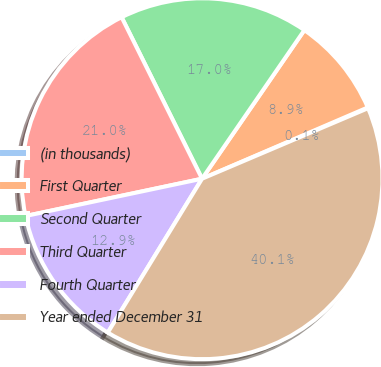Convert chart to OTSL. <chart><loc_0><loc_0><loc_500><loc_500><pie_chart><fcel>(in thousands)<fcel>First Quarter<fcel>Second Quarter<fcel>Third Quarter<fcel>Fourth Quarter<fcel>Year ended December 31<nl><fcel>0.07%<fcel>8.94%<fcel>16.95%<fcel>20.96%<fcel>12.94%<fcel>40.14%<nl></chart> 